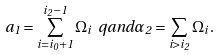Convert formula to latex. <formula><loc_0><loc_0><loc_500><loc_500>a _ { 1 } = \sum _ { i = i _ { 0 } + 1 } ^ { i _ { 2 } - 1 } \Omega _ { i } \ q a n d \alpha _ { 2 } = \sum _ { i > i _ { 2 } } \Omega _ { i } \, .</formula> 